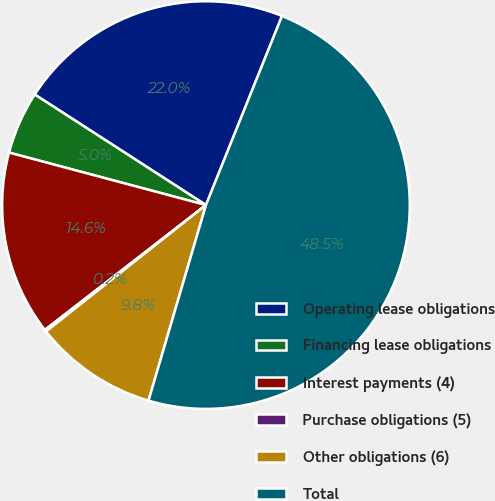Convert chart to OTSL. <chart><loc_0><loc_0><loc_500><loc_500><pie_chart><fcel>Operating lease obligations<fcel>Financing lease obligations<fcel>Interest payments (4)<fcel>Purchase obligations (5)<fcel>Other obligations (6)<fcel>Total<nl><fcel>21.96%<fcel>4.98%<fcel>14.64%<fcel>0.15%<fcel>9.81%<fcel>48.46%<nl></chart> 